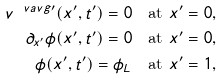<formula> <loc_0><loc_0><loc_500><loc_500>v ^ { \ v a v g \prime } ( x ^ { \prime } , t ^ { \prime } ) = 0 & \quad \text {at $x^{\prime}=0$} , \\ \partial _ { x ^ { \prime } } \phi ( x ^ { \prime } , t ^ { \prime } ) = 0 & \quad \text {at $x^{\prime}=0$} , \\ \phi ( x ^ { \prime } , t ^ { \prime } ) = \phi _ { L } & \quad \text {at $x^{\prime}=1$} ,</formula> 